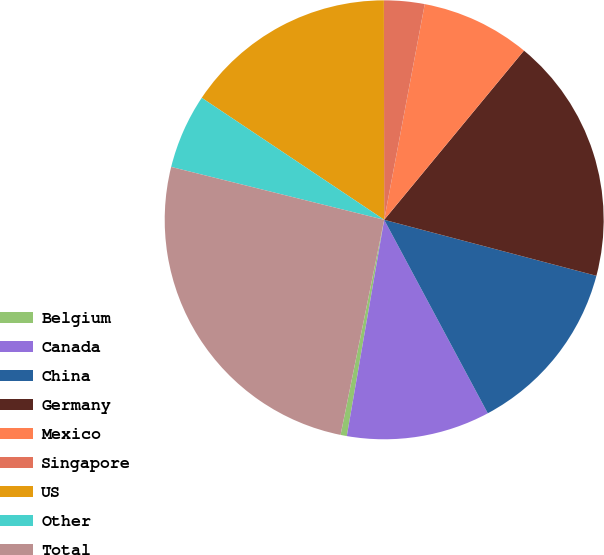Convert chart to OTSL. <chart><loc_0><loc_0><loc_500><loc_500><pie_chart><fcel>Belgium<fcel>Canada<fcel>China<fcel>Germany<fcel>Mexico<fcel>Singapore<fcel>US<fcel>Other<fcel>Total<nl><fcel>0.46%<fcel>10.55%<fcel>13.07%<fcel>18.12%<fcel>8.03%<fcel>2.98%<fcel>15.6%<fcel>5.51%<fcel>25.69%<nl></chart> 